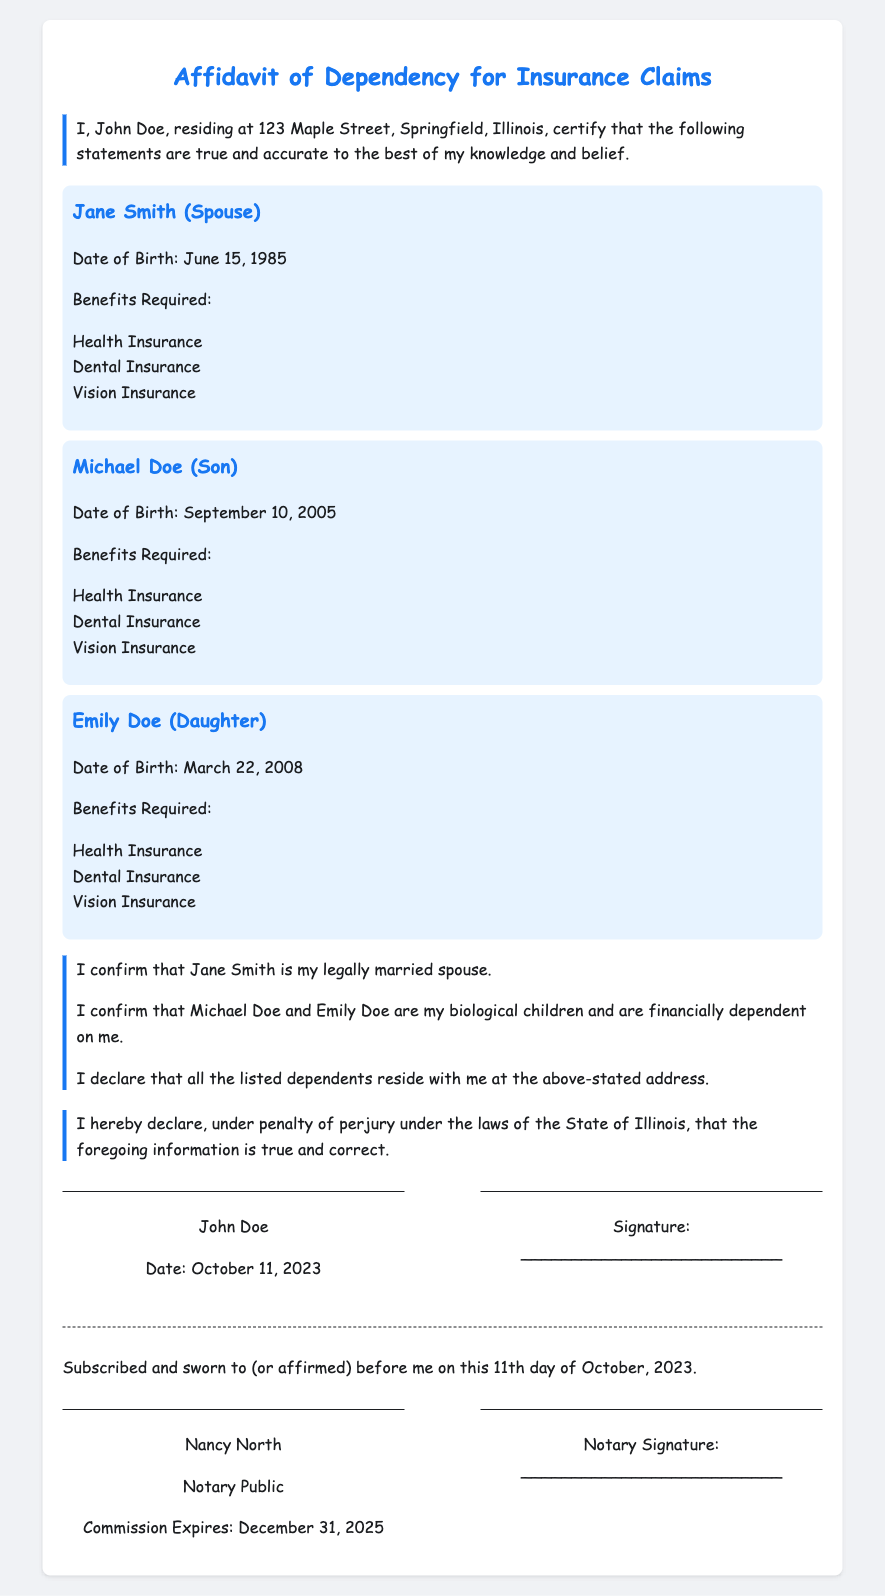What is the name of the spouse? The document states that the spouse's name is mentioned as Jane Smith.
Answer: Jane Smith What is the date of birth of Michael Doe? The document provides the date of birth for Michael Doe as September 10, 2005.
Answer: September 10, 2005 What benefits are required for Emily Doe? The required benefits listed for Emily Doe include health, dental, and vision insurance.
Answer: Health Insurance, Dental Insurance, Vision Insurance How many dependents are listed in the affidavit? The document lists a total of three dependents: Jane Smith, Michael Doe, and Emily Doe.
Answer: Three Who is the Notary Public? The document contains a signature box for the Notary with the name Nancy North.
Answer: Nancy North Is Jane Smith a spouse or a child? The relationship stated in the document indicates Jane Smith is the spouse.
Answer: Spouse What is the expiration date of the Notary's commission? The expiration date for the Notary's commission as stated in the document is December 31, 2025.
Answer: December 31, 2025 What is the address mentioned in the affidavit? The document states the address where the signer resides as 123 Maple Street, Springfield, Illinois.
Answer: 123 Maple Street, Springfield, Illinois 